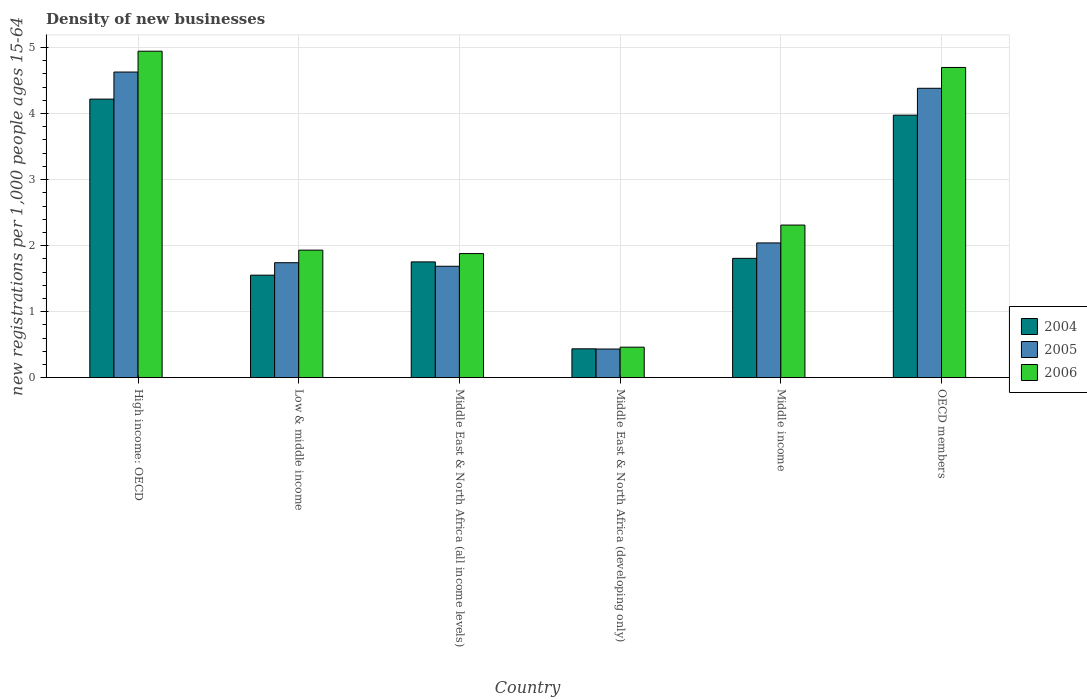How many different coloured bars are there?
Your answer should be compact. 3. How many groups of bars are there?
Provide a succinct answer. 6. How many bars are there on the 3rd tick from the left?
Provide a succinct answer. 3. How many bars are there on the 6th tick from the right?
Make the answer very short. 3. What is the label of the 6th group of bars from the left?
Your answer should be very brief. OECD members. In how many cases, is the number of bars for a given country not equal to the number of legend labels?
Provide a succinct answer. 0. What is the number of new registrations in 2005 in Middle East & North Africa (all income levels)?
Your response must be concise. 1.69. Across all countries, what is the maximum number of new registrations in 2005?
Offer a terse response. 4.63. Across all countries, what is the minimum number of new registrations in 2004?
Your answer should be very brief. 0.44. In which country was the number of new registrations in 2005 maximum?
Give a very brief answer. High income: OECD. In which country was the number of new registrations in 2004 minimum?
Your answer should be very brief. Middle East & North Africa (developing only). What is the total number of new registrations in 2005 in the graph?
Your response must be concise. 14.92. What is the difference between the number of new registrations in 2005 in Low & middle income and that in OECD members?
Ensure brevity in your answer.  -2.64. What is the difference between the number of new registrations in 2006 in Middle East & North Africa (all income levels) and the number of new registrations in 2004 in Middle East & North Africa (developing only)?
Your answer should be very brief. 1.44. What is the average number of new registrations in 2004 per country?
Ensure brevity in your answer.  2.29. What is the difference between the number of new registrations of/in 2006 and number of new registrations of/in 2005 in Middle East & North Africa (developing only)?
Give a very brief answer. 0.03. What is the ratio of the number of new registrations in 2005 in High income: OECD to that in Low & middle income?
Provide a succinct answer. 2.66. Is the number of new registrations in 2006 in Middle income less than that in OECD members?
Your answer should be very brief. Yes. Is the difference between the number of new registrations in 2006 in Low & middle income and Middle East & North Africa (all income levels) greater than the difference between the number of new registrations in 2005 in Low & middle income and Middle East & North Africa (all income levels)?
Ensure brevity in your answer.  No. What is the difference between the highest and the second highest number of new registrations in 2004?
Your answer should be very brief. -2.17. What is the difference between the highest and the lowest number of new registrations in 2004?
Offer a very short reply. 3.78. Is the sum of the number of new registrations in 2004 in Middle East & North Africa (developing only) and OECD members greater than the maximum number of new registrations in 2005 across all countries?
Provide a short and direct response. No. What does the 2nd bar from the left in High income: OECD represents?
Your answer should be compact. 2005. How many bars are there?
Make the answer very short. 18. Are all the bars in the graph horizontal?
Ensure brevity in your answer.  No. How many countries are there in the graph?
Make the answer very short. 6. Are the values on the major ticks of Y-axis written in scientific E-notation?
Ensure brevity in your answer.  No. Where does the legend appear in the graph?
Provide a succinct answer. Center right. How many legend labels are there?
Offer a terse response. 3. What is the title of the graph?
Offer a very short reply. Density of new businesses. What is the label or title of the Y-axis?
Provide a succinct answer. New registrations per 1,0 people ages 15-64. What is the new registrations per 1,000 people ages 15-64 of 2004 in High income: OECD?
Your answer should be compact. 4.22. What is the new registrations per 1,000 people ages 15-64 of 2005 in High income: OECD?
Keep it short and to the point. 4.63. What is the new registrations per 1,000 people ages 15-64 of 2006 in High income: OECD?
Your answer should be very brief. 4.94. What is the new registrations per 1,000 people ages 15-64 in 2004 in Low & middle income?
Make the answer very short. 1.55. What is the new registrations per 1,000 people ages 15-64 in 2005 in Low & middle income?
Offer a terse response. 1.74. What is the new registrations per 1,000 people ages 15-64 of 2006 in Low & middle income?
Your response must be concise. 1.93. What is the new registrations per 1,000 people ages 15-64 of 2004 in Middle East & North Africa (all income levels)?
Give a very brief answer. 1.75. What is the new registrations per 1,000 people ages 15-64 in 2005 in Middle East & North Africa (all income levels)?
Make the answer very short. 1.69. What is the new registrations per 1,000 people ages 15-64 in 2006 in Middle East & North Africa (all income levels)?
Your answer should be very brief. 1.88. What is the new registrations per 1,000 people ages 15-64 in 2004 in Middle East & North Africa (developing only)?
Your answer should be compact. 0.44. What is the new registrations per 1,000 people ages 15-64 in 2005 in Middle East & North Africa (developing only)?
Provide a short and direct response. 0.43. What is the new registrations per 1,000 people ages 15-64 of 2006 in Middle East & North Africa (developing only)?
Ensure brevity in your answer.  0.46. What is the new registrations per 1,000 people ages 15-64 of 2004 in Middle income?
Your answer should be very brief. 1.81. What is the new registrations per 1,000 people ages 15-64 of 2005 in Middle income?
Keep it short and to the point. 2.04. What is the new registrations per 1,000 people ages 15-64 of 2006 in Middle income?
Make the answer very short. 2.31. What is the new registrations per 1,000 people ages 15-64 in 2004 in OECD members?
Make the answer very short. 3.98. What is the new registrations per 1,000 people ages 15-64 in 2005 in OECD members?
Give a very brief answer. 4.38. What is the new registrations per 1,000 people ages 15-64 of 2006 in OECD members?
Offer a very short reply. 4.7. Across all countries, what is the maximum new registrations per 1,000 people ages 15-64 in 2004?
Your answer should be very brief. 4.22. Across all countries, what is the maximum new registrations per 1,000 people ages 15-64 in 2005?
Give a very brief answer. 4.63. Across all countries, what is the maximum new registrations per 1,000 people ages 15-64 of 2006?
Provide a succinct answer. 4.94. Across all countries, what is the minimum new registrations per 1,000 people ages 15-64 of 2004?
Give a very brief answer. 0.44. Across all countries, what is the minimum new registrations per 1,000 people ages 15-64 in 2005?
Provide a short and direct response. 0.43. Across all countries, what is the minimum new registrations per 1,000 people ages 15-64 of 2006?
Provide a short and direct response. 0.46. What is the total new registrations per 1,000 people ages 15-64 of 2004 in the graph?
Your answer should be very brief. 13.74. What is the total new registrations per 1,000 people ages 15-64 of 2005 in the graph?
Provide a succinct answer. 14.92. What is the total new registrations per 1,000 people ages 15-64 of 2006 in the graph?
Provide a short and direct response. 16.23. What is the difference between the new registrations per 1,000 people ages 15-64 of 2004 in High income: OECD and that in Low & middle income?
Offer a terse response. 2.67. What is the difference between the new registrations per 1,000 people ages 15-64 in 2005 in High income: OECD and that in Low & middle income?
Your response must be concise. 2.89. What is the difference between the new registrations per 1,000 people ages 15-64 in 2006 in High income: OECD and that in Low & middle income?
Offer a terse response. 3.01. What is the difference between the new registrations per 1,000 people ages 15-64 in 2004 in High income: OECD and that in Middle East & North Africa (all income levels)?
Give a very brief answer. 2.47. What is the difference between the new registrations per 1,000 people ages 15-64 of 2005 in High income: OECD and that in Middle East & North Africa (all income levels)?
Your response must be concise. 2.94. What is the difference between the new registrations per 1,000 people ages 15-64 of 2006 in High income: OECD and that in Middle East & North Africa (all income levels)?
Ensure brevity in your answer.  3.07. What is the difference between the new registrations per 1,000 people ages 15-64 in 2004 in High income: OECD and that in Middle East & North Africa (developing only)?
Provide a succinct answer. 3.78. What is the difference between the new registrations per 1,000 people ages 15-64 in 2005 in High income: OECD and that in Middle East & North Africa (developing only)?
Make the answer very short. 4.2. What is the difference between the new registrations per 1,000 people ages 15-64 in 2006 in High income: OECD and that in Middle East & North Africa (developing only)?
Provide a short and direct response. 4.48. What is the difference between the new registrations per 1,000 people ages 15-64 in 2004 in High income: OECD and that in Middle income?
Your answer should be very brief. 2.41. What is the difference between the new registrations per 1,000 people ages 15-64 of 2005 in High income: OECD and that in Middle income?
Your answer should be compact. 2.59. What is the difference between the new registrations per 1,000 people ages 15-64 of 2006 in High income: OECD and that in Middle income?
Provide a short and direct response. 2.63. What is the difference between the new registrations per 1,000 people ages 15-64 in 2004 in High income: OECD and that in OECD members?
Give a very brief answer. 0.24. What is the difference between the new registrations per 1,000 people ages 15-64 in 2005 in High income: OECD and that in OECD members?
Your response must be concise. 0.25. What is the difference between the new registrations per 1,000 people ages 15-64 of 2006 in High income: OECD and that in OECD members?
Offer a very short reply. 0.25. What is the difference between the new registrations per 1,000 people ages 15-64 in 2004 in Low & middle income and that in Middle East & North Africa (all income levels)?
Keep it short and to the point. -0.2. What is the difference between the new registrations per 1,000 people ages 15-64 of 2005 in Low & middle income and that in Middle East & North Africa (all income levels)?
Provide a succinct answer. 0.05. What is the difference between the new registrations per 1,000 people ages 15-64 of 2006 in Low & middle income and that in Middle East & North Africa (all income levels)?
Provide a succinct answer. 0.05. What is the difference between the new registrations per 1,000 people ages 15-64 in 2004 in Low & middle income and that in Middle East & North Africa (developing only)?
Offer a very short reply. 1.12. What is the difference between the new registrations per 1,000 people ages 15-64 of 2005 in Low & middle income and that in Middle East & North Africa (developing only)?
Ensure brevity in your answer.  1.31. What is the difference between the new registrations per 1,000 people ages 15-64 in 2006 in Low & middle income and that in Middle East & North Africa (developing only)?
Ensure brevity in your answer.  1.47. What is the difference between the new registrations per 1,000 people ages 15-64 of 2004 in Low & middle income and that in Middle income?
Make the answer very short. -0.25. What is the difference between the new registrations per 1,000 people ages 15-64 in 2005 in Low & middle income and that in Middle income?
Your answer should be very brief. -0.3. What is the difference between the new registrations per 1,000 people ages 15-64 of 2006 in Low & middle income and that in Middle income?
Ensure brevity in your answer.  -0.38. What is the difference between the new registrations per 1,000 people ages 15-64 of 2004 in Low & middle income and that in OECD members?
Your answer should be compact. -2.42. What is the difference between the new registrations per 1,000 people ages 15-64 in 2005 in Low & middle income and that in OECD members?
Provide a succinct answer. -2.64. What is the difference between the new registrations per 1,000 people ages 15-64 of 2006 in Low & middle income and that in OECD members?
Your answer should be compact. -2.77. What is the difference between the new registrations per 1,000 people ages 15-64 of 2004 in Middle East & North Africa (all income levels) and that in Middle East & North Africa (developing only)?
Keep it short and to the point. 1.32. What is the difference between the new registrations per 1,000 people ages 15-64 of 2005 in Middle East & North Africa (all income levels) and that in Middle East & North Africa (developing only)?
Give a very brief answer. 1.25. What is the difference between the new registrations per 1,000 people ages 15-64 of 2006 in Middle East & North Africa (all income levels) and that in Middle East & North Africa (developing only)?
Keep it short and to the point. 1.42. What is the difference between the new registrations per 1,000 people ages 15-64 of 2004 in Middle East & North Africa (all income levels) and that in Middle income?
Offer a terse response. -0.05. What is the difference between the new registrations per 1,000 people ages 15-64 of 2005 in Middle East & North Africa (all income levels) and that in Middle income?
Your answer should be very brief. -0.35. What is the difference between the new registrations per 1,000 people ages 15-64 of 2006 in Middle East & North Africa (all income levels) and that in Middle income?
Offer a very short reply. -0.43. What is the difference between the new registrations per 1,000 people ages 15-64 of 2004 in Middle East & North Africa (all income levels) and that in OECD members?
Your response must be concise. -2.22. What is the difference between the new registrations per 1,000 people ages 15-64 in 2005 in Middle East & North Africa (all income levels) and that in OECD members?
Keep it short and to the point. -2.7. What is the difference between the new registrations per 1,000 people ages 15-64 in 2006 in Middle East & North Africa (all income levels) and that in OECD members?
Provide a succinct answer. -2.82. What is the difference between the new registrations per 1,000 people ages 15-64 in 2004 in Middle East & North Africa (developing only) and that in Middle income?
Your answer should be very brief. -1.37. What is the difference between the new registrations per 1,000 people ages 15-64 of 2005 in Middle East & North Africa (developing only) and that in Middle income?
Offer a very short reply. -1.61. What is the difference between the new registrations per 1,000 people ages 15-64 of 2006 in Middle East & North Africa (developing only) and that in Middle income?
Your response must be concise. -1.85. What is the difference between the new registrations per 1,000 people ages 15-64 of 2004 in Middle East & North Africa (developing only) and that in OECD members?
Provide a succinct answer. -3.54. What is the difference between the new registrations per 1,000 people ages 15-64 of 2005 in Middle East & North Africa (developing only) and that in OECD members?
Your response must be concise. -3.95. What is the difference between the new registrations per 1,000 people ages 15-64 in 2006 in Middle East & North Africa (developing only) and that in OECD members?
Provide a succinct answer. -4.24. What is the difference between the new registrations per 1,000 people ages 15-64 of 2004 in Middle income and that in OECD members?
Provide a succinct answer. -2.17. What is the difference between the new registrations per 1,000 people ages 15-64 of 2005 in Middle income and that in OECD members?
Give a very brief answer. -2.34. What is the difference between the new registrations per 1,000 people ages 15-64 of 2006 in Middle income and that in OECD members?
Ensure brevity in your answer.  -2.39. What is the difference between the new registrations per 1,000 people ages 15-64 of 2004 in High income: OECD and the new registrations per 1,000 people ages 15-64 of 2005 in Low & middle income?
Give a very brief answer. 2.48. What is the difference between the new registrations per 1,000 people ages 15-64 in 2004 in High income: OECD and the new registrations per 1,000 people ages 15-64 in 2006 in Low & middle income?
Provide a short and direct response. 2.29. What is the difference between the new registrations per 1,000 people ages 15-64 of 2005 in High income: OECD and the new registrations per 1,000 people ages 15-64 of 2006 in Low & middle income?
Offer a very short reply. 2.7. What is the difference between the new registrations per 1,000 people ages 15-64 in 2004 in High income: OECD and the new registrations per 1,000 people ages 15-64 in 2005 in Middle East & North Africa (all income levels)?
Your answer should be very brief. 2.53. What is the difference between the new registrations per 1,000 people ages 15-64 in 2004 in High income: OECD and the new registrations per 1,000 people ages 15-64 in 2006 in Middle East & North Africa (all income levels)?
Provide a succinct answer. 2.34. What is the difference between the new registrations per 1,000 people ages 15-64 of 2005 in High income: OECD and the new registrations per 1,000 people ages 15-64 of 2006 in Middle East & North Africa (all income levels)?
Ensure brevity in your answer.  2.75. What is the difference between the new registrations per 1,000 people ages 15-64 in 2004 in High income: OECD and the new registrations per 1,000 people ages 15-64 in 2005 in Middle East & North Africa (developing only)?
Make the answer very short. 3.79. What is the difference between the new registrations per 1,000 people ages 15-64 in 2004 in High income: OECD and the new registrations per 1,000 people ages 15-64 in 2006 in Middle East & North Africa (developing only)?
Make the answer very short. 3.76. What is the difference between the new registrations per 1,000 people ages 15-64 in 2005 in High income: OECD and the new registrations per 1,000 people ages 15-64 in 2006 in Middle East & North Africa (developing only)?
Keep it short and to the point. 4.17. What is the difference between the new registrations per 1,000 people ages 15-64 of 2004 in High income: OECD and the new registrations per 1,000 people ages 15-64 of 2005 in Middle income?
Provide a short and direct response. 2.18. What is the difference between the new registrations per 1,000 people ages 15-64 in 2004 in High income: OECD and the new registrations per 1,000 people ages 15-64 in 2006 in Middle income?
Provide a short and direct response. 1.91. What is the difference between the new registrations per 1,000 people ages 15-64 of 2005 in High income: OECD and the new registrations per 1,000 people ages 15-64 of 2006 in Middle income?
Provide a short and direct response. 2.32. What is the difference between the new registrations per 1,000 people ages 15-64 in 2004 in High income: OECD and the new registrations per 1,000 people ages 15-64 in 2005 in OECD members?
Offer a very short reply. -0.16. What is the difference between the new registrations per 1,000 people ages 15-64 in 2004 in High income: OECD and the new registrations per 1,000 people ages 15-64 in 2006 in OECD members?
Offer a terse response. -0.48. What is the difference between the new registrations per 1,000 people ages 15-64 in 2005 in High income: OECD and the new registrations per 1,000 people ages 15-64 in 2006 in OECD members?
Your answer should be very brief. -0.07. What is the difference between the new registrations per 1,000 people ages 15-64 in 2004 in Low & middle income and the new registrations per 1,000 people ages 15-64 in 2005 in Middle East & North Africa (all income levels)?
Offer a very short reply. -0.13. What is the difference between the new registrations per 1,000 people ages 15-64 of 2004 in Low & middle income and the new registrations per 1,000 people ages 15-64 of 2006 in Middle East & North Africa (all income levels)?
Your response must be concise. -0.33. What is the difference between the new registrations per 1,000 people ages 15-64 of 2005 in Low & middle income and the new registrations per 1,000 people ages 15-64 of 2006 in Middle East & North Africa (all income levels)?
Keep it short and to the point. -0.14. What is the difference between the new registrations per 1,000 people ages 15-64 of 2004 in Low & middle income and the new registrations per 1,000 people ages 15-64 of 2005 in Middle East & North Africa (developing only)?
Your answer should be very brief. 1.12. What is the difference between the new registrations per 1,000 people ages 15-64 in 2005 in Low & middle income and the new registrations per 1,000 people ages 15-64 in 2006 in Middle East & North Africa (developing only)?
Your response must be concise. 1.28. What is the difference between the new registrations per 1,000 people ages 15-64 of 2004 in Low & middle income and the new registrations per 1,000 people ages 15-64 of 2005 in Middle income?
Keep it short and to the point. -0.49. What is the difference between the new registrations per 1,000 people ages 15-64 of 2004 in Low & middle income and the new registrations per 1,000 people ages 15-64 of 2006 in Middle income?
Give a very brief answer. -0.76. What is the difference between the new registrations per 1,000 people ages 15-64 in 2005 in Low & middle income and the new registrations per 1,000 people ages 15-64 in 2006 in Middle income?
Your answer should be very brief. -0.57. What is the difference between the new registrations per 1,000 people ages 15-64 in 2004 in Low & middle income and the new registrations per 1,000 people ages 15-64 in 2005 in OECD members?
Keep it short and to the point. -2.83. What is the difference between the new registrations per 1,000 people ages 15-64 of 2004 in Low & middle income and the new registrations per 1,000 people ages 15-64 of 2006 in OECD members?
Your answer should be compact. -3.15. What is the difference between the new registrations per 1,000 people ages 15-64 in 2005 in Low & middle income and the new registrations per 1,000 people ages 15-64 in 2006 in OECD members?
Ensure brevity in your answer.  -2.96. What is the difference between the new registrations per 1,000 people ages 15-64 in 2004 in Middle East & North Africa (all income levels) and the new registrations per 1,000 people ages 15-64 in 2005 in Middle East & North Africa (developing only)?
Your response must be concise. 1.32. What is the difference between the new registrations per 1,000 people ages 15-64 in 2004 in Middle East & North Africa (all income levels) and the new registrations per 1,000 people ages 15-64 in 2006 in Middle East & North Africa (developing only)?
Keep it short and to the point. 1.29. What is the difference between the new registrations per 1,000 people ages 15-64 in 2005 in Middle East & North Africa (all income levels) and the new registrations per 1,000 people ages 15-64 in 2006 in Middle East & North Africa (developing only)?
Make the answer very short. 1.23. What is the difference between the new registrations per 1,000 people ages 15-64 of 2004 in Middle East & North Africa (all income levels) and the new registrations per 1,000 people ages 15-64 of 2005 in Middle income?
Your answer should be very brief. -0.29. What is the difference between the new registrations per 1,000 people ages 15-64 of 2004 in Middle East & North Africa (all income levels) and the new registrations per 1,000 people ages 15-64 of 2006 in Middle income?
Offer a very short reply. -0.56. What is the difference between the new registrations per 1,000 people ages 15-64 in 2005 in Middle East & North Africa (all income levels) and the new registrations per 1,000 people ages 15-64 in 2006 in Middle income?
Your answer should be compact. -0.62. What is the difference between the new registrations per 1,000 people ages 15-64 in 2004 in Middle East & North Africa (all income levels) and the new registrations per 1,000 people ages 15-64 in 2005 in OECD members?
Offer a terse response. -2.63. What is the difference between the new registrations per 1,000 people ages 15-64 in 2004 in Middle East & North Africa (all income levels) and the new registrations per 1,000 people ages 15-64 in 2006 in OECD members?
Provide a short and direct response. -2.95. What is the difference between the new registrations per 1,000 people ages 15-64 in 2005 in Middle East & North Africa (all income levels) and the new registrations per 1,000 people ages 15-64 in 2006 in OECD members?
Provide a succinct answer. -3.01. What is the difference between the new registrations per 1,000 people ages 15-64 of 2004 in Middle East & North Africa (developing only) and the new registrations per 1,000 people ages 15-64 of 2005 in Middle income?
Make the answer very short. -1.6. What is the difference between the new registrations per 1,000 people ages 15-64 in 2004 in Middle East & North Africa (developing only) and the new registrations per 1,000 people ages 15-64 in 2006 in Middle income?
Provide a short and direct response. -1.87. What is the difference between the new registrations per 1,000 people ages 15-64 in 2005 in Middle East & North Africa (developing only) and the new registrations per 1,000 people ages 15-64 in 2006 in Middle income?
Offer a very short reply. -1.88. What is the difference between the new registrations per 1,000 people ages 15-64 of 2004 in Middle East & North Africa (developing only) and the new registrations per 1,000 people ages 15-64 of 2005 in OECD members?
Give a very brief answer. -3.95. What is the difference between the new registrations per 1,000 people ages 15-64 in 2004 in Middle East & North Africa (developing only) and the new registrations per 1,000 people ages 15-64 in 2006 in OECD members?
Your answer should be very brief. -4.26. What is the difference between the new registrations per 1,000 people ages 15-64 of 2005 in Middle East & North Africa (developing only) and the new registrations per 1,000 people ages 15-64 of 2006 in OECD members?
Keep it short and to the point. -4.26. What is the difference between the new registrations per 1,000 people ages 15-64 in 2004 in Middle income and the new registrations per 1,000 people ages 15-64 in 2005 in OECD members?
Your answer should be compact. -2.58. What is the difference between the new registrations per 1,000 people ages 15-64 in 2004 in Middle income and the new registrations per 1,000 people ages 15-64 in 2006 in OECD members?
Your answer should be compact. -2.89. What is the difference between the new registrations per 1,000 people ages 15-64 of 2005 in Middle income and the new registrations per 1,000 people ages 15-64 of 2006 in OECD members?
Your response must be concise. -2.66. What is the average new registrations per 1,000 people ages 15-64 of 2004 per country?
Give a very brief answer. 2.29. What is the average new registrations per 1,000 people ages 15-64 of 2005 per country?
Keep it short and to the point. 2.49. What is the average new registrations per 1,000 people ages 15-64 in 2006 per country?
Offer a terse response. 2.7. What is the difference between the new registrations per 1,000 people ages 15-64 in 2004 and new registrations per 1,000 people ages 15-64 in 2005 in High income: OECD?
Offer a terse response. -0.41. What is the difference between the new registrations per 1,000 people ages 15-64 in 2004 and new registrations per 1,000 people ages 15-64 in 2006 in High income: OECD?
Provide a short and direct response. -0.73. What is the difference between the new registrations per 1,000 people ages 15-64 in 2005 and new registrations per 1,000 people ages 15-64 in 2006 in High income: OECD?
Give a very brief answer. -0.32. What is the difference between the new registrations per 1,000 people ages 15-64 of 2004 and new registrations per 1,000 people ages 15-64 of 2005 in Low & middle income?
Provide a short and direct response. -0.19. What is the difference between the new registrations per 1,000 people ages 15-64 in 2004 and new registrations per 1,000 people ages 15-64 in 2006 in Low & middle income?
Provide a short and direct response. -0.38. What is the difference between the new registrations per 1,000 people ages 15-64 of 2005 and new registrations per 1,000 people ages 15-64 of 2006 in Low & middle income?
Give a very brief answer. -0.19. What is the difference between the new registrations per 1,000 people ages 15-64 of 2004 and new registrations per 1,000 people ages 15-64 of 2005 in Middle East & North Africa (all income levels)?
Make the answer very short. 0.07. What is the difference between the new registrations per 1,000 people ages 15-64 of 2004 and new registrations per 1,000 people ages 15-64 of 2006 in Middle East & North Africa (all income levels)?
Keep it short and to the point. -0.13. What is the difference between the new registrations per 1,000 people ages 15-64 in 2005 and new registrations per 1,000 people ages 15-64 in 2006 in Middle East & North Africa (all income levels)?
Keep it short and to the point. -0.19. What is the difference between the new registrations per 1,000 people ages 15-64 of 2004 and new registrations per 1,000 people ages 15-64 of 2005 in Middle East & North Africa (developing only)?
Make the answer very short. 0. What is the difference between the new registrations per 1,000 people ages 15-64 of 2004 and new registrations per 1,000 people ages 15-64 of 2006 in Middle East & North Africa (developing only)?
Your response must be concise. -0.02. What is the difference between the new registrations per 1,000 people ages 15-64 of 2005 and new registrations per 1,000 people ages 15-64 of 2006 in Middle East & North Africa (developing only)?
Make the answer very short. -0.03. What is the difference between the new registrations per 1,000 people ages 15-64 of 2004 and new registrations per 1,000 people ages 15-64 of 2005 in Middle income?
Provide a short and direct response. -0.23. What is the difference between the new registrations per 1,000 people ages 15-64 of 2004 and new registrations per 1,000 people ages 15-64 of 2006 in Middle income?
Your answer should be very brief. -0.5. What is the difference between the new registrations per 1,000 people ages 15-64 of 2005 and new registrations per 1,000 people ages 15-64 of 2006 in Middle income?
Your response must be concise. -0.27. What is the difference between the new registrations per 1,000 people ages 15-64 of 2004 and new registrations per 1,000 people ages 15-64 of 2005 in OECD members?
Provide a succinct answer. -0.41. What is the difference between the new registrations per 1,000 people ages 15-64 in 2004 and new registrations per 1,000 people ages 15-64 in 2006 in OECD members?
Make the answer very short. -0.72. What is the difference between the new registrations per 1,000 people ages 15-64 of 2005 and new registrations per 1,000 people ages 15-64 of 2006 in OECD members?
Ensure brevity in your answer.  -0.32. What is the ratio of the new registrations per 1,000 people ages 15-64 of 2004 in High income: OECD to that in Low & middle income?
Your answer should be very brief. 2.72. What is the ratio of the new registrations per 1,000 people ages 15-64 in 2005 in High income: OECD to that in Low & middle income?
Your response must be concise. 2.66. What is the ratio of the new registrations per 1,000 people ages 15-64 of 2006 in High income: OECD to that in Low & middle income?
Ensure brevity in your answer.  2.56. What is the ratio of the new registrations per 1,000 people ages 15-64 of 2004 in High income: OECD to that in Middle East & North Africa (all income levels)?
Your response must be concise. 2.41. What is the ratio of the new registrations per 1,000 people ages 15-64 of 2005 in High income: OECD to that in Middle East & North Africa (all income levels)?
Keep it short and to the point. 2.74. What is the ratio of the new registrations per 1,000 people ages 15-64 in 2006 in High income: OECD to that in Middle East & North Africa (all income levels)?
Give a very brief answer. 2.63. What is the ratio of the new registrations per 1,000 people ages 15-64 in 2004 in High income: OECD to that in Middle East & North Africa (developing only)?
Give a very brief answer. 9.66. What is the ratio of the new registrations per 1,000 people ages 15-64 in 2005 in High income: OECD to that in Middle East & North Africa (developing only)?
Your answer should be compact. 10.67. What is the ratio of the new registrations per 1,000 people ages 15-64 in 2006 in High income: OECD to that in Middle East & North Africa (developing only)?
Make the answer very short. 10.71. What is the ratio of the new registrations per 1,000 people ages 15-64 of 2004 in High income: OECD to that in Middle income?
Keep it short and to the point. 2.33. What is the ratio of the new registrations per 1,000 people ages 15-64 of 2005 in High income: OECD to that in Middle income?
Your answer should be very brief. 2.27. What is the ratio of the new registrations per 1,000 people ages 15-64 of 2006 in High income: OECD to that in Middle income?
Your answer should be compact. 2.14. What is the ratio of the new registrations per 1,000 people ages 15-64 of 2004 in High income: OECD to that in OECD members?
Provide a short and direct response. 1.06. What is the ratio of the new registrations per 1,000 people ages 15-64 of 2005 in High income: OECD to that in OECD members?
Offer a very short reply. 1.06. What is the ratio of the new registrations per 1,000 people ages 15-64 of 2006 in High income: OECD to that in OECD members?
Give a very brief answer. 1.05. What is the ratio of the new registrations per 1,000 people ages 15-64 in 2004 in Low & middle income to that in Middle East & North Africa (all income levels)?
Ensure brevity in your answer.  0.89. What is the ratio of the new registrations per 1,000 people ages 15-64 in 2005 in Low & middle income to that in Middle East & North Africa (all income levels)?
Your response must be concise. 1.03. What is the ratio of the new registrations per 1,000 people ages 15-64 of 2006 in Low & middle income to that in Middle East & North Africa (all income levels)?
Provide a short and direct response. 1.03. What is the ratio of the new registrations per 1,000 people ages 15-64 in 2004 in Low & middle income to that in Middle East & North Africa (developing only)?
Provide a succinct answer. 3.55. What is the ratio of the new registrations per 1,000 people ages 15-64 of 2005 in Low & middle income to that in Middle East & North Africa (developing only)?
Make the answer very short. 4.01. What is the ratio of the new registrations per 1,000 people ages 15-64 in 2006 in Low & middle income to that in Middle East & North Africa (developing only)?
Make the answer very short. 4.18. What is the ratio of the new registrations per 1,000 people ages 15-64 of 2004 in Low & middle income to that in Middle income?
Ensure brevity in your answer.  0.86. What is the ratio of the new registrations per 1,000 people ages 15-64 of 2005 in Low & middle income to that in Middle income?
Ensure brevity in your answer.  0.85. What is the ratio of the new registrations per 1,000 people ages 15-64 of 2006 in Low & middle income to that in Middle income?
Your response must be concise. 0.84. What is the ratio of the new registrations per 1,000 people ages 15-64 of 2004 in Low & middle income to that in OECD members?
Your answer should be very brief. 0.39. What is the ratio of the new registrations per 1,000 people ages 15-64 of 2005 in Low & middle income to that in OECD members?
Give a very brief answer. 0.4. What is the ratio of the new registrations per 1,000 people ages 15-64 in 2006 in Low & middle income to that in OECD members?
Provide a short and direct response. 0.41. What is the ratio of the new registrations per 1,000 people ages 15-64 in 2004 in Middle East & North Africa (all income levels) to that in Middle East & North Africa (developing only)?
Offer a very short reply. 4.01. What is the ratio of the new registrations per 1,000 people ages 15-64 of 2005 in Middle East & North Africa (all income levels) to that in Middle East & North Africa (developing only)?
Keep it short and to the point. 3.89. What is the ratio of the new registrations per 1,000 people ages 15-64 of 2006 in Middle East & North Africa (all income levels) to that in Middle East & North Africa (developing only)?
Give a very brief answer. 4.07. What is the ratio of the new registrations per 1,000 people ages 15-64 of 2004 in Middle East & North Africa (all income levels) to that in Middle income?
Your answer should be very brief. 0.97. What is the ratio of the new registrations per 1,000 people ages 15-64 in 2005 in Middle East & North Africa (all income levels) to that in Middle income?
Make the answer very short. 0.83. What is the ratio of the new registrations per 1,000 people ages 15-64 in 2006 in Middle East & North Africa (all income levels) to that in Middle income?
Keep it short and to the point. 0.81. What is the ratio of the new registrations per 1,000 people ages 15-64 in 2004 in Middle East & North Africa (all income levels) to that in OECD members?
Keep it short and to the point. 0.44. What is the ratio of the new registrations per 1,000 people ages 15-64 in 2005 in Middle East & North Africa (all income levels) to that in OECD members?
Make the answer very short. 0.39. What is the ratio of the new registrations per 1,000 people ages 15-64 in 2004 in Middle East & North Africa (developing only) to that in Middle income?
Offer a terse response. 0.24. What is the ratio of the new registrations per 1,000 people ages 15-64 of 2005 in Middle East & North Africa (developing only) to that in Middle income?
Offer a terse response. 0.21. What is the ratio of the new registrations per 1,000 people ages 15-64 in 2006 in Middle East & North Africa (developing only) to that in Middle income?
Your response must be concise. 0.2. What is the ratio of the new registrations per 1,000 people ages 15-64 in 2004 in Middle East & North Africa (developing only) to that in OECD members?
Give a very brief answer. 0.11. What is the ratio of the new registrations per 1,000 people ages 15-64 of 2005 in Middle East & North Africa (developing only) to that in OECD members?
Keep it short and to the point. 0.1. What is the ratio of the new registrations per 1,000 people ages 15-64 in 2006 in Middle East & North Africa (developing only) to that in OECD members?
Ensure brevity in your answer.  0.1. What is the ratio of the new registrations per 1,000 people ages 15-64 in 2004 in Middle income to that in OECD members?
Provide a short and direct response. 0.45. What is the ratio of the new registrations per 1,000 people ages 15-64 in 2005 in Middle income to that in OECD members?
Ensure brevity in your answer.  0.47. What is the ratio of the new registrations per 1,000 people ages 15-64 in 2006 in Middle income to that in OECD members?
Keep it short and to the point. 0.49. What is the difference between the highest and the second highest new registrations per 1,000 people ages 15-64 in 2004?
Keep it short and to the point. 0.24. What is the difference between the highest and the second highest new registrations per 1,000 people ages 15-64 of 2005?
Give a very brief answer. 0.25. What is the difference between the highest and the second highest new registrations per 1,000 people ages 15-64 in 2006?
Ensure brevity in your answer.  0.25. What is the difference between the highest and the lowest new registrations per 1,000 people ages 15-64 in 2004?
Offer a terse response. 3.78. What is the difference between the highest and the lowest new registrations per 1,000 people ages 15-64 in 2005?
Provide a succinct answer. 4.2. What is the difference between the highest and the lowest new registrations per 1,000 people ages 15-64 in 2006?
Your response must be concise. 4.48. 